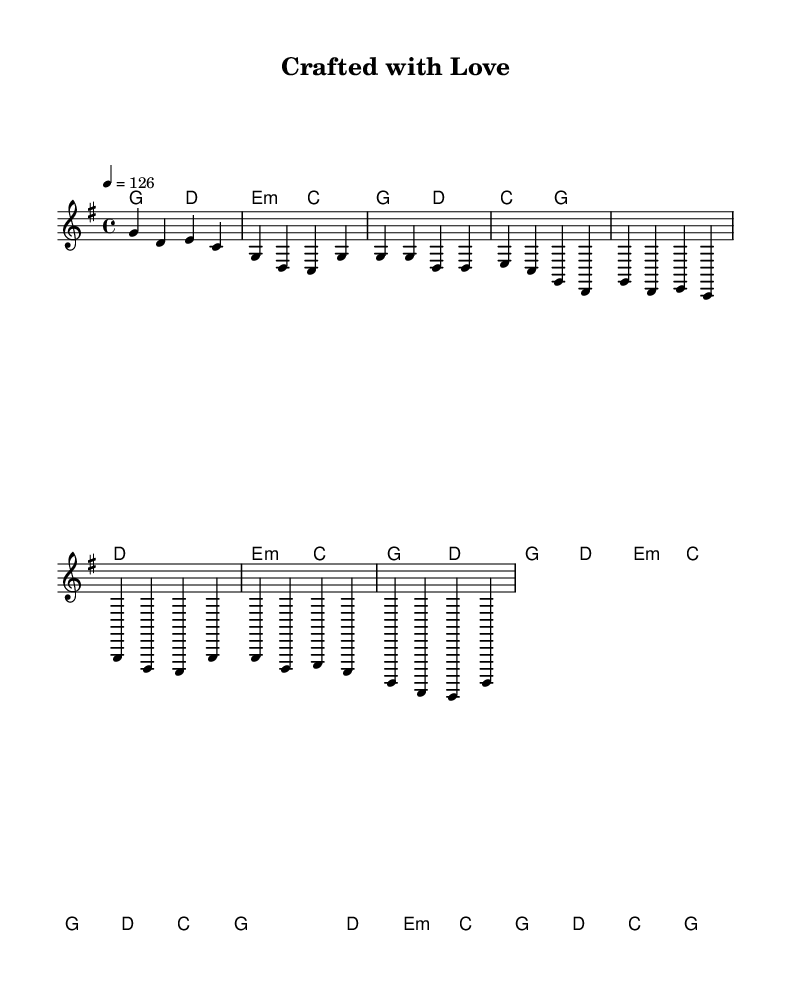What is the key signature of this music? The key signature is G major, which has one sharp (F#). This can be determined from the global section of the LilyPond code where it specifies \key g \major.
Answer: G major What is the time signature of the piece? The time signature is 4/4. This is indicated in the global section by the \time 4/4 directive.
Answer: 4/4 What is the tempo marking for this piece? The tempo marking is 126 beats per minute. This is stated in the global section where it shows \tempo 4 = 126, which implies the speed at which the music should be played.
Answer: 126 How many measures are in the chorus section? The chorus section consists of four measures. By analyzing the notation in the melody starts from the start of the chorus and counts until the end, we see two distinct sets of measures, leading to a total of four.
Answer: 4 What type of chords are predominantly used in this piece? The predominant chord types are major and minor chords. This can be deduced from the chord sequence in the harmonies section of the score, where chords like G, D, E minor, and C are used, all of which are common in country music.
Answer: Major and minor Is the structure of the song typical for country music? Yes, the structure follows a common pattern found in country music with an intro, verse, and chorus. The progression and repetition of sections reflect the storytelling tradition typical of the genre.
Answer: Yes 